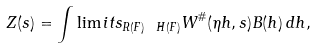Convert formula to latex. <formula><loc_0><loc_0><loc_500><loc_500>Z ( s ) = \int \lim i t s _ { R ( F ) \ H ( F ) } W ^ { \# } ( \eta h , s ) B ( h ) \, d h ,</formula> 